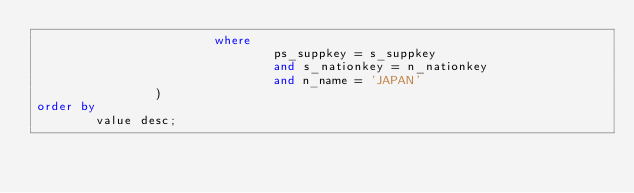<code> <loc_0><loc_0><loc_500><loc_500><_SQL_>												where
																ps_suppkey = s_suppkey
																and s_nationkey = n_nationkey
																and n_name = 'JAPAN'
								)
order by
				value desc;
</code> 